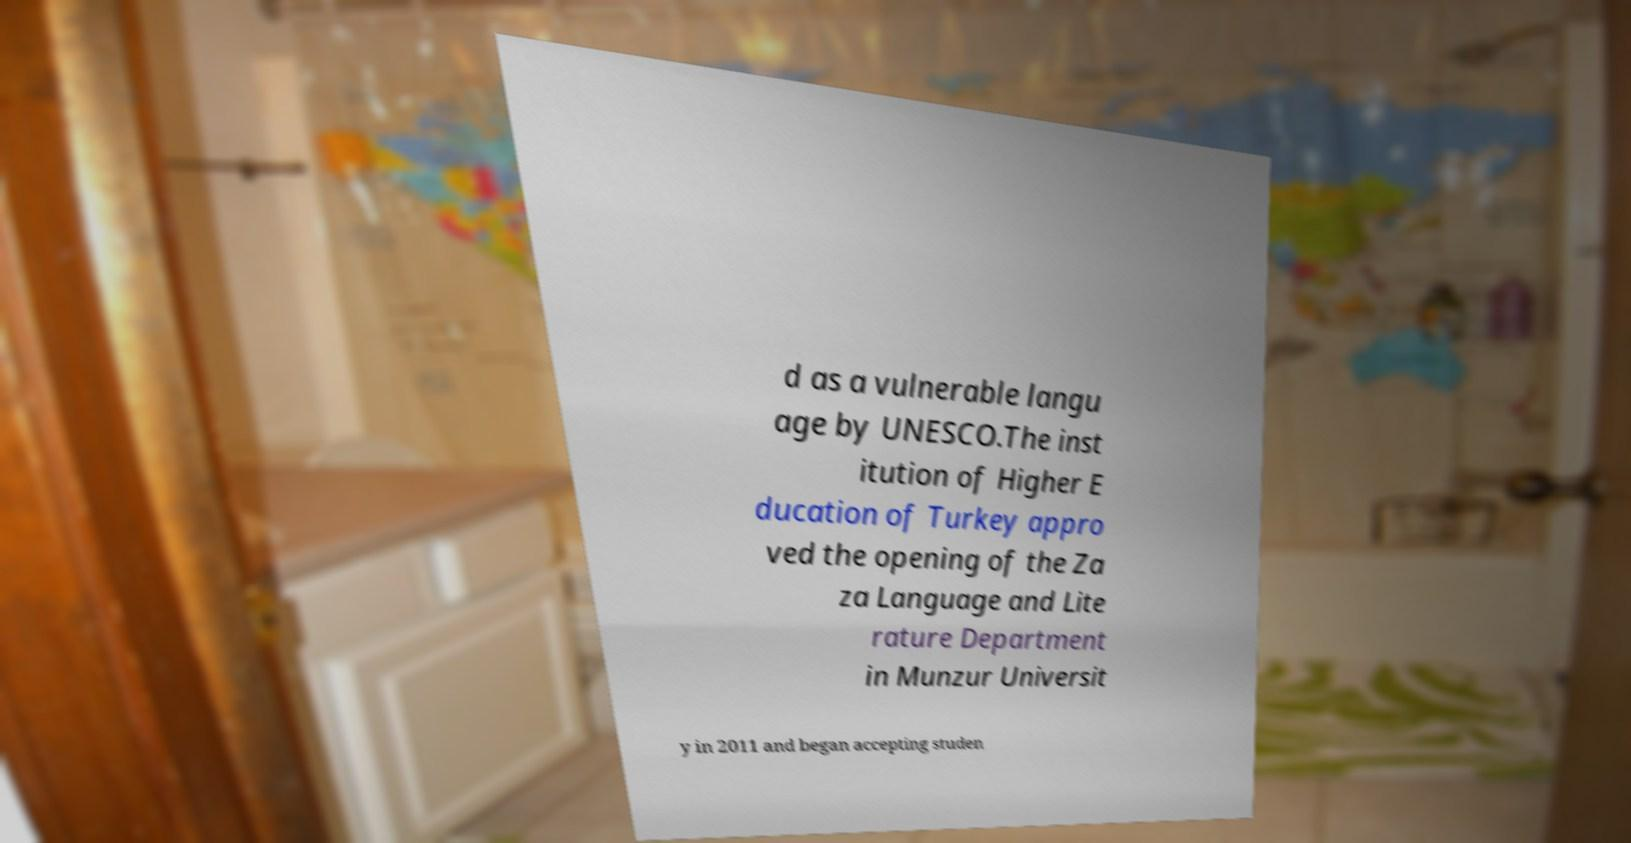What messages or text are displayed in this image? I need them in a readable, typed format. d as a vulnerable langu age by UNESCO.The inst itution of Higher E ducation of Turkey appro ved the opening of the Za za Language and Lite rature Department in Munzur Universit y in 2011 and began accepting studen 